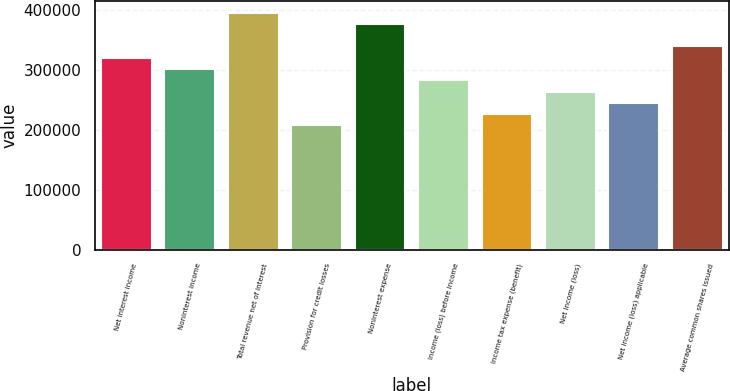<chart> <loc_0><loc_0><loc_500><loc_500><bar_chart><fcel>Net interest income<fcel>Noninterest income<fcel>Total revenue net of interest<fcel>Provision for credit losses<fcel>Noninterest expense<fcel>Income (loss) before income<fcel>Income tax expense (benefit)<fcel>Net income (loss)<fcel>Net income (loss) applicable<fcel>Average common shares issued<nl><fcel>319840<fcel>301026<fcel>395096<fcel>206955<fcel>376282<fcel>282211<fcel>225769<fcel>263397<fcel>244583<fcel>338654<nl></chart> 